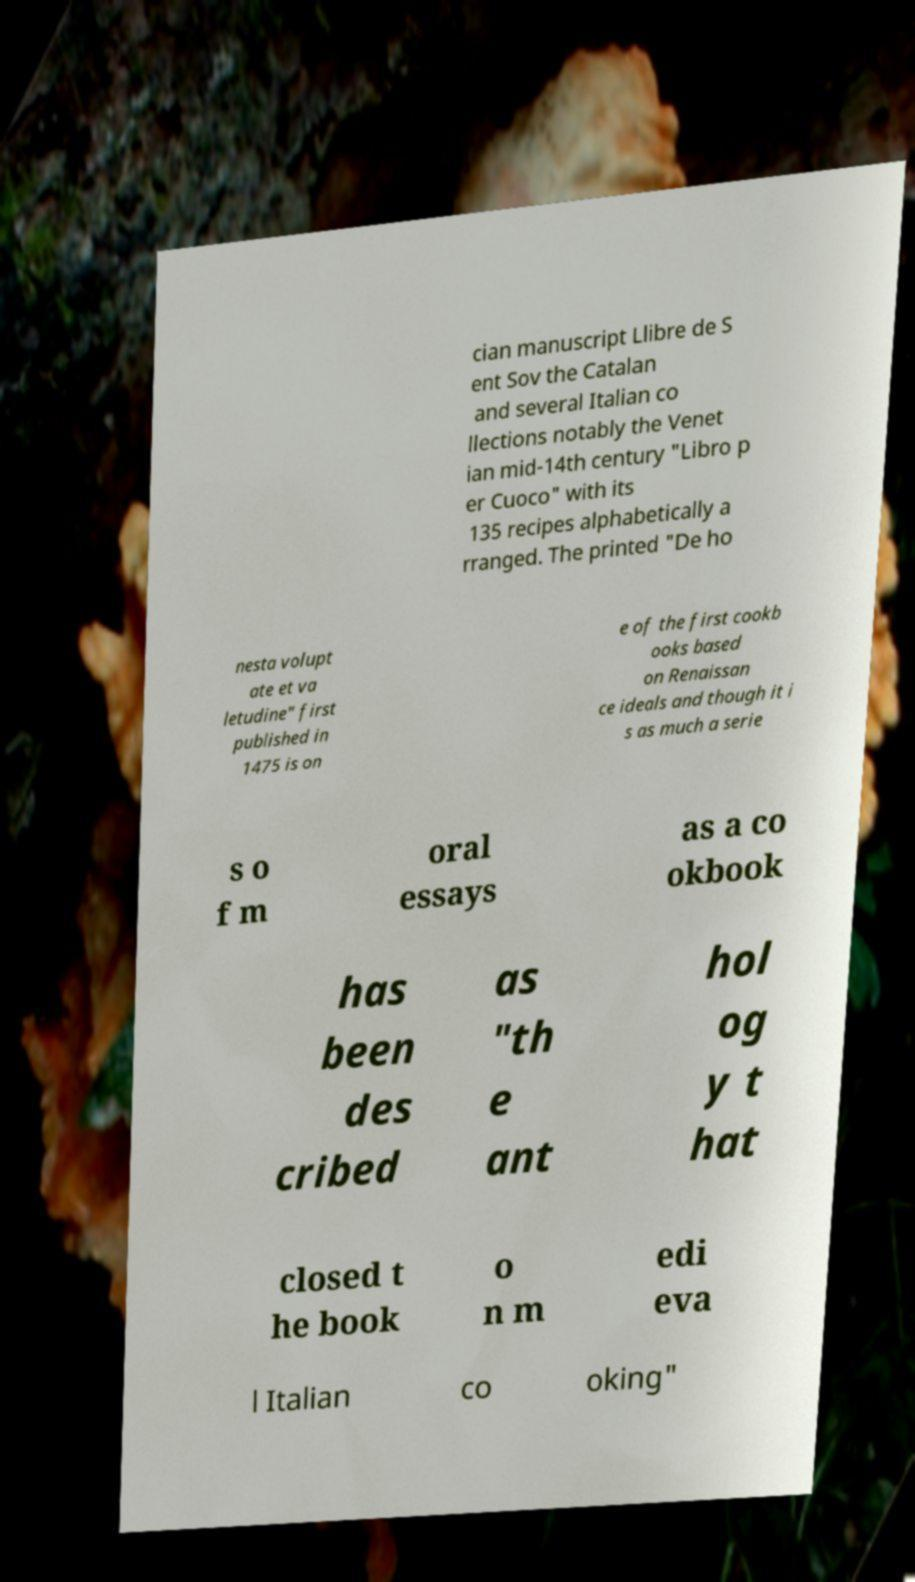Could you extract and type out the text from this image? cian manuscript Llibre de S ent Sov the Catalan and several Italian co llections notably the Venet ian mid-14th century "Libro p er Cuoco" with its 135 recipes alphabetically a rranged. The printed "De ho nesta volupt ate et va letudine" first published in 1475 is on e of the first cookb ooks based on Renaissan ce ideals and though it i s as much a serie s o f m oral essays as a co okbook has been des cribed as "th e ant hol og y t hat closed t he book o n m edi eva l Italian co oking" 